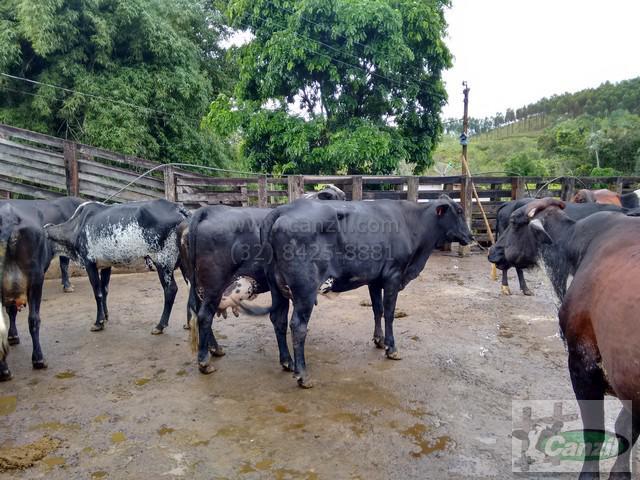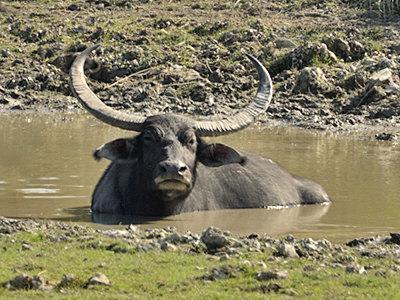The first image is the image on the left, the second image is the image on the right. Examine the images to the left and right. Is the description "At least one animal is in the water in the image on the right." accurate? Answer yes or no. Yes. The first image is the image on the left, the second image is the image on the right. Evaluate the accuracy of this statement regarding the images: "All animals in the right image have horns.". Is it true? Answer yes or no. Yes. 